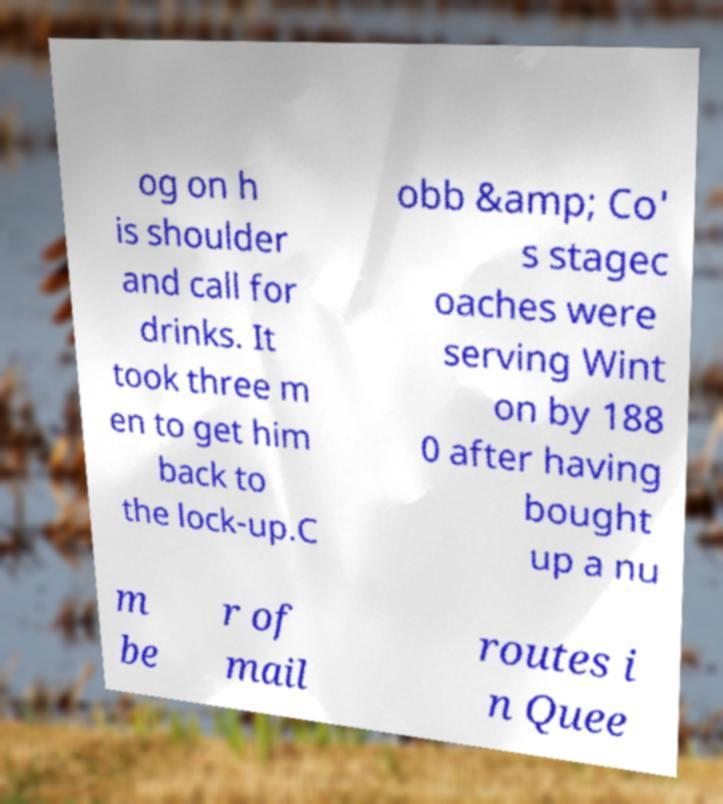What messages or text are displayed in this image? I need them in a readable, typed format. og on h is shoulder and call for drinks. It took three m en to get him back to the lock-up.C obb &amp; Co' s stagec oaches were serving Wint on by 188 0 after having bought up a nu m be r of mail routes i n Quee 